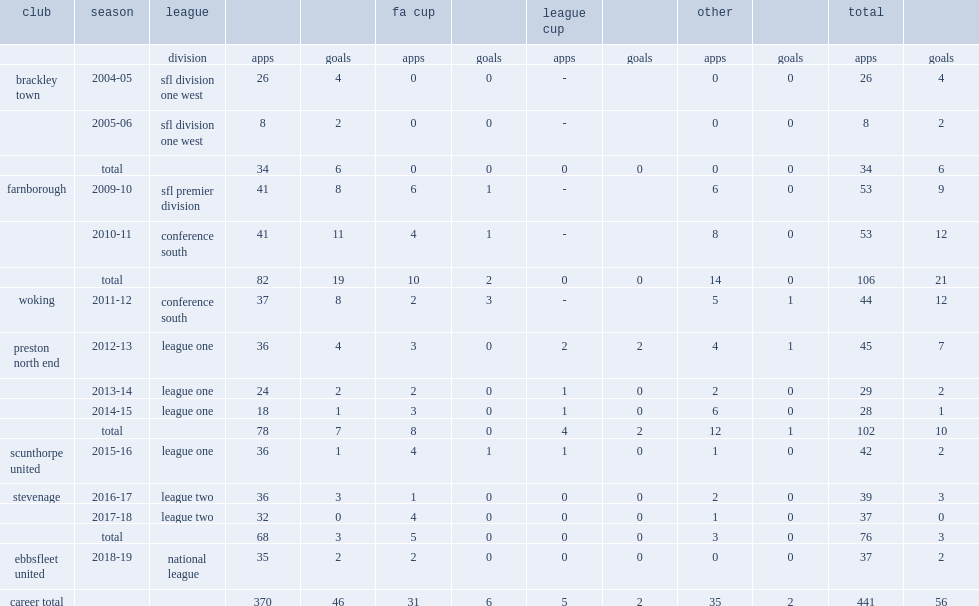In the 2016-17 season, which league did king join side stevenage? League two. 